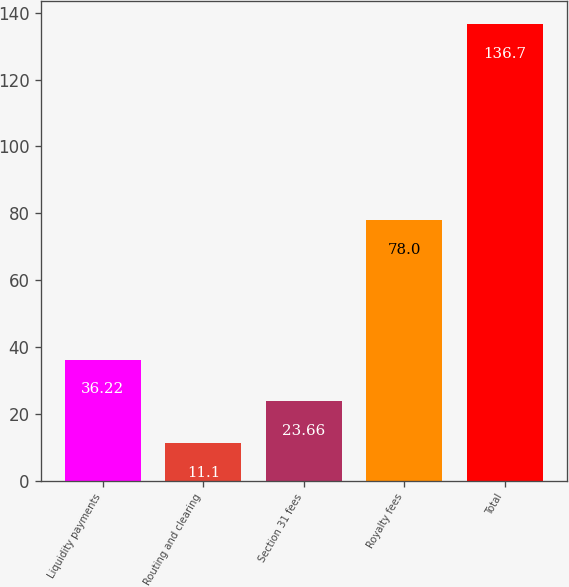Convert chart. <chart><loc_0><loc_0><loc_500><loc_500><bar_chart><fcel>Liquidity payments<fcel>Routing and clearing<fcel>Section 31 fees<fcel>Royalty fees<fcel>Total<nl><fcel>36.22<fcel>11.1<fcel>23.66<fcel>78<fcel>136.7<nl></chart> 